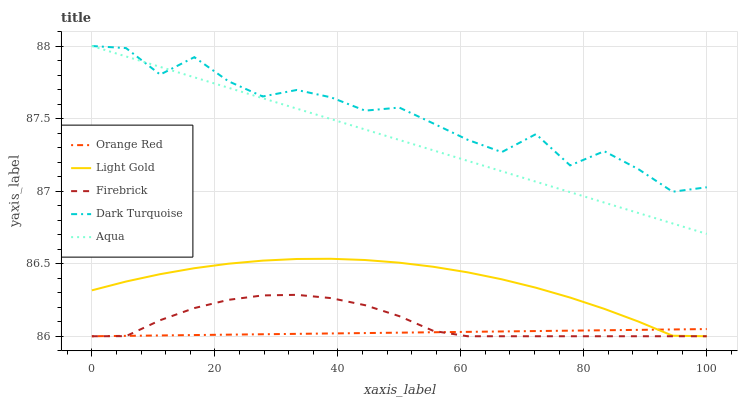Does Orange Red have the minimum area under the curve?
Answer yes or no. Yes. Does Dark Turquoise have the maximum area under the curve?
Answer yes or no. Yes. Does Firebrick have the minimum area under the curve?
Answer yes or no. No. Does Firebrick have the maximum area under the curve?
Answer yes or no. No. Is Orange Red the smoothest?
Answer yes or no. Yes. Is Dark Turquoise the roughest?
Answer yes or no. Yes. Is Firebrick the smoothest?
Answer yes or no. No. Is Firebrick the roughest?
Answer yes or no. No. Does Firebrick have the lowest value?
Answer yes or no. Yes. Does Dark Turquoise have the lowest value?
Answer yes or no. No. Does Dark Turquoise have the highest value?
Answer yes or no. Yes. Does Firebrick have the highest value?
Answer yes or no. No. Is Orange Red less than Dark Turquoise?
Answer yes or no. Yes. Is Dark Turquoise greater than Firebrick?
Answer yes or no. Yes. Does Light Gold intersect Orange Red?
Answer yes or no. Yes. Is Light Gold less than Orange Red?
Answer yes or no. No. Is Light Gold greater than Orange Red?
Answer yes or no. No. Does Orange Red intersect Dark Turquoise?
Answer yes or no. No. 